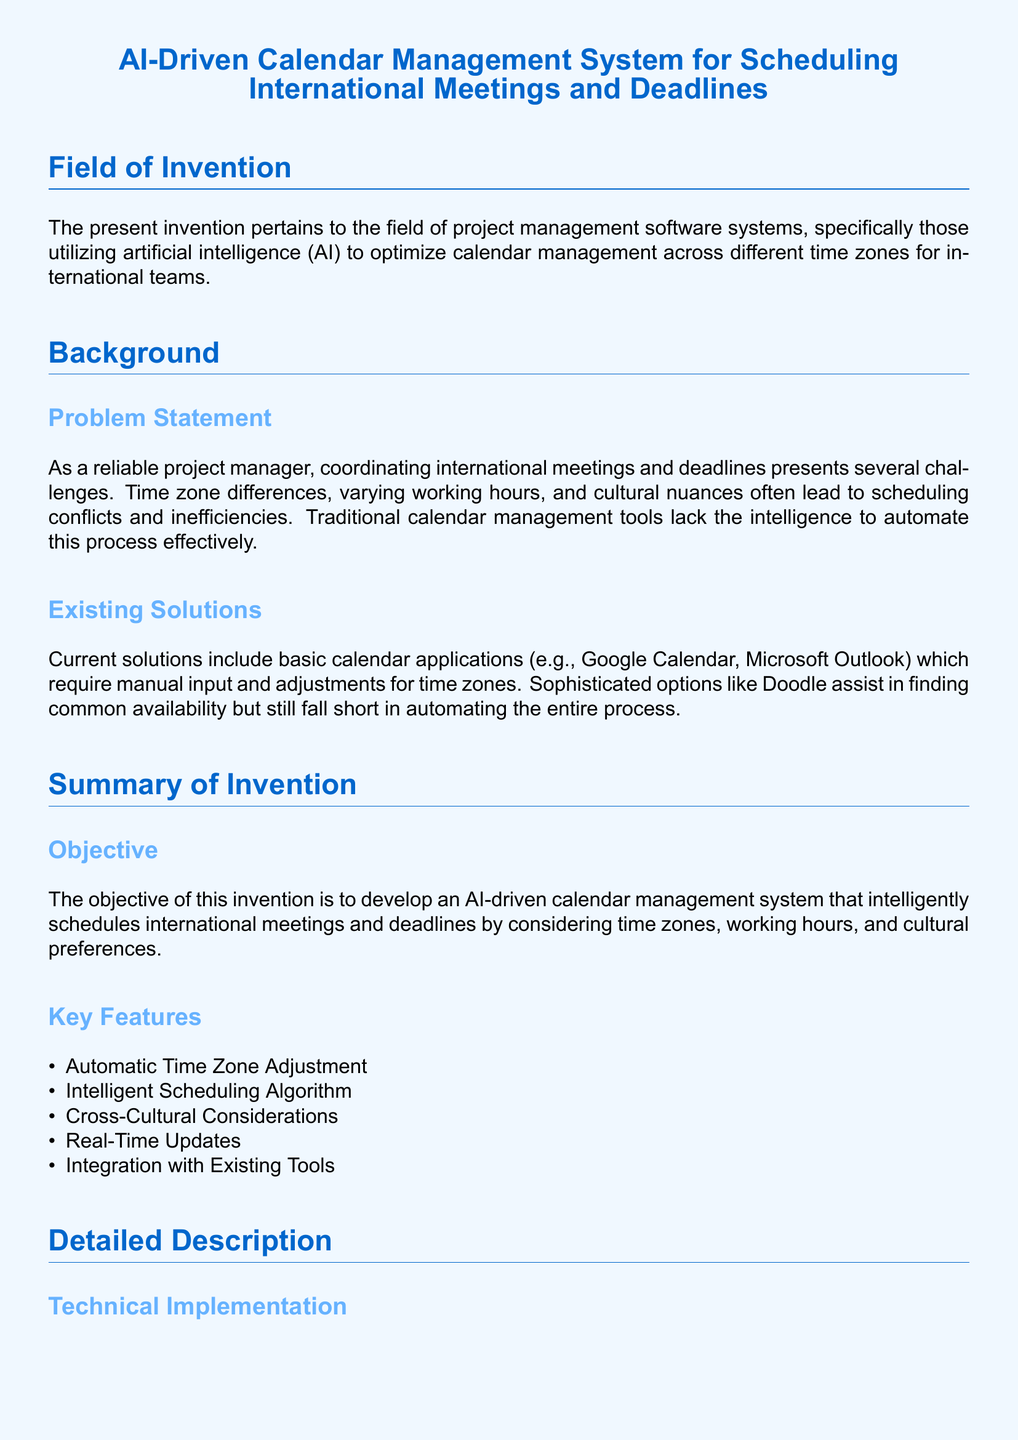What is the main focus of the invention? The main focus of the invention pertains to project management software systems utilizing artificial intelligence to optimize calendar management across different time zones for international teams.
Answer: project management software systems What problem does the invention aim to solve? The invention aims to solve the challenges of coordinating international meetings and deadlines, such as time zone differences and scheduling conflicts.
Answer: scheduling conflicts What is a key feature of the AI-driven calendar management system? A key feature is the automatic time zone adjustment that handles conversion of meeting times to local participant times.
Answer: automatic time zone adjustment What method does the AI-scheduling algorithm employ? The AI-scheduling algorithm employs machine learning techniques to learn from past scheduling patterns and preferences.
Answer: machine learning techniques Which module considers public holidays and local working hours? The cultural contextualization module incorporates public holidays, local working hours, and cultural events.
Answer: cultural contextualization module How does the system ensure real-time synchronization? The system utilizes webhooks and APIs to ensure real-time synchronization of schedules.
Answer: webhooks and APIs What is the purpose of the notification system? The notification system provides real-time updates and alerts to all participants regarding scheduling changes.
Answer: real-time updates and alerts What type of calendar applications does the document mention as existing solutions? The document mentions basic calendar applications such as Google Calendar and Microsoft Outlook.
Answer: Google Calendar and Microsoft Outlook What implementation does the document specifically mention for security? The document mentions implementing robust encryption protocols to protect sensitive scheduling data.
Answer: encryption protocols 